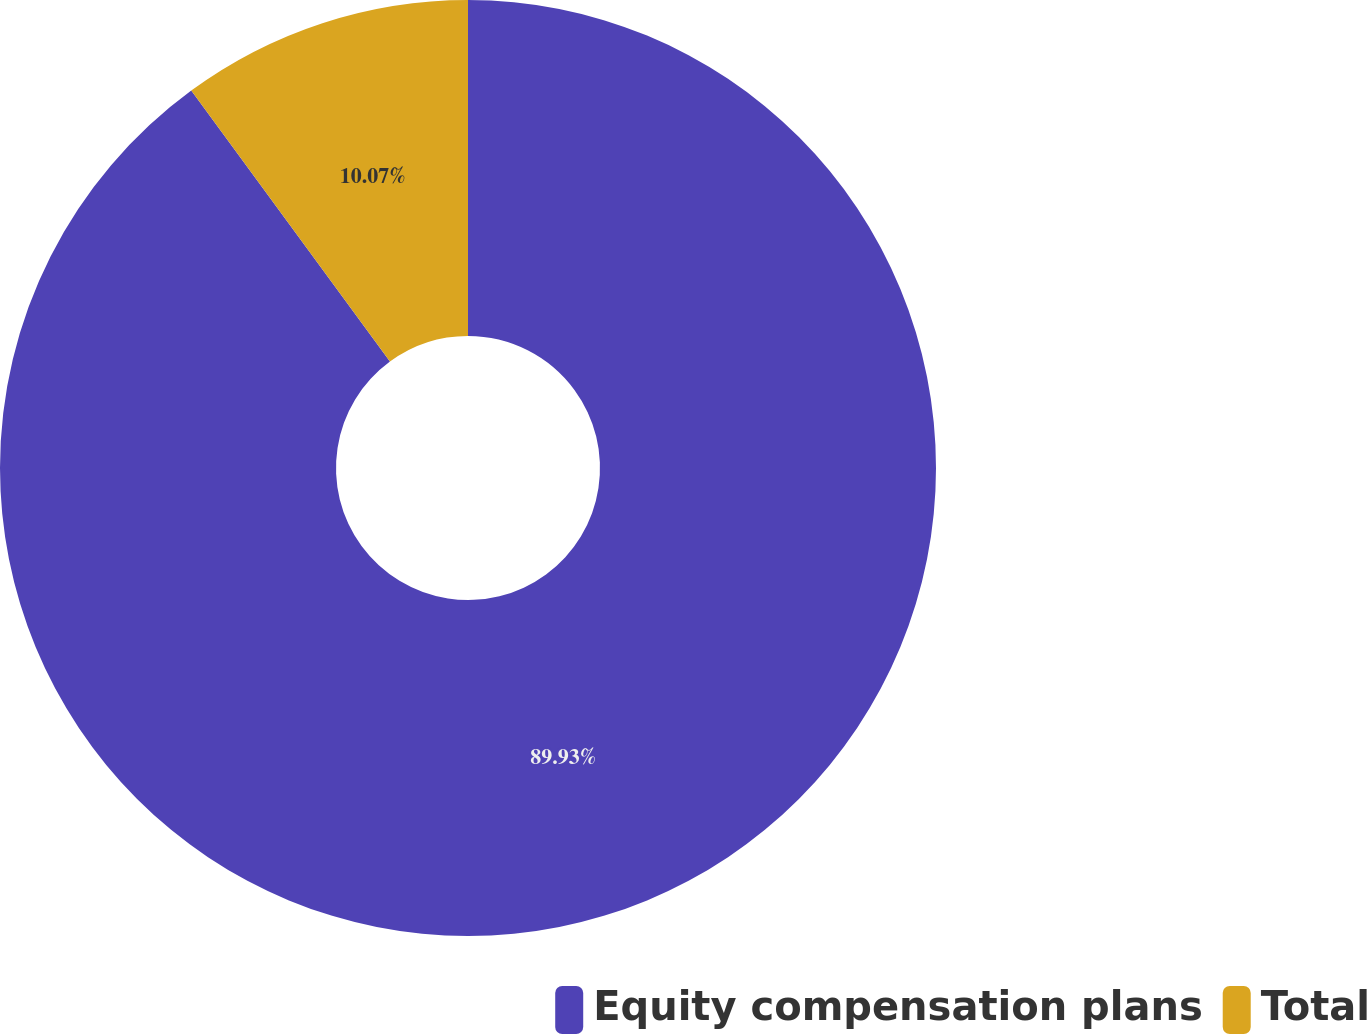<chart> <loc_0><loc_0><loc_500><loc_500><pie_chart><fcel>Equity compensation plans<fcel>Total<nl><fcel>89.93%<fcel>10.07%<nl></chart> 